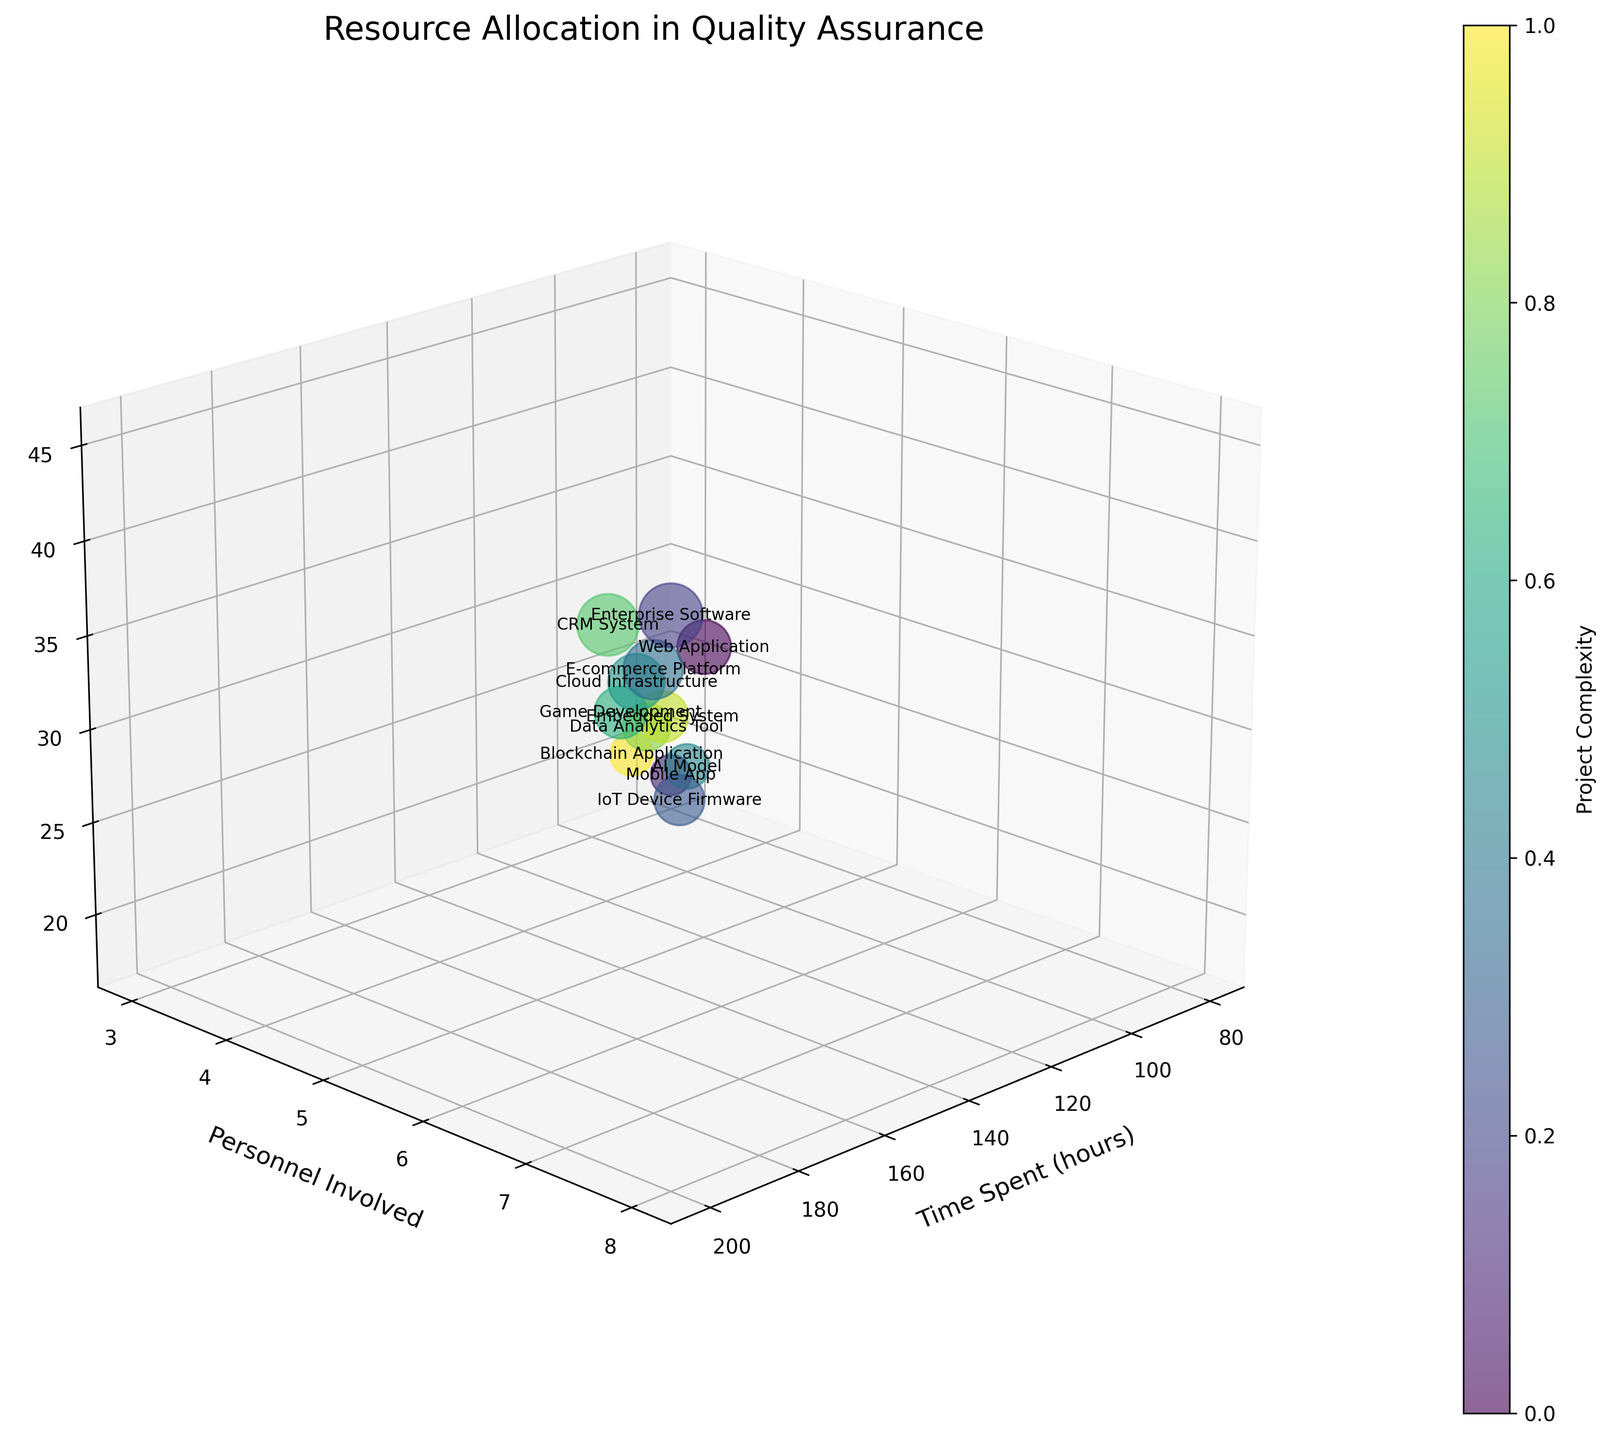What is the title of the figure? The title can be found at the top of the figure, which summarizes the main idea or subject of the plot.
Answer: Resource Allocation in Quality Assurance Which axis represents 'Time Spent (hours)'? The axis labels usually specify what each axis represents. Look for the label that says 'Time Spent (hours)'.
Answer: X-axis How many project types are represented in the figure? Count the unique labels associated with each bubble in the scatter plot to determine the number of project types.
Answer: 12 Which project type involves the most personnel? Identify the bubble with the highest value on the 'Personnel Involved' axis and see which project type is tagged.
Answer: Enterprise Software How many defects are resolved for the Mobile App project type? Look for the bubble labeled 'Mobile App' and identify the value on the 'Defects Resolved' axis.
Answer: 18 Which two project types have the closest number of defects resolved? Compare the values on the 'Defects Resolved' axis for each project type and find the two which are closest in number.
Answer: AI Model and Blockchain Application What is the range of time spent across all project types? Identify the minimum and maximum values on the 'Time Spent (hours)' axis and compute the difference.
Answer: 200 - 80 = 120 What is the average number of personnel involved across all project types? Add up all the values on the 'Personnel Involved' axis and divide by the number of project types.
Answer: (5 + 3 + 8 + 6 + 7 + 4 + 6 + 5 + 7 + 4 + 5 + 3) / 12 = 63 / 12 ≈ 5.25 Which project type resolved the most defects in the least amount of time? Compare the bubbles based on the highest 'Defects Resolved' and lowest 'Time Spent (hours)', then identify the project type.
Answer: Web Application How does time spent correlate with the number of defects resolved? Observe the general trend of the bubbles moving from left to right and bottom to top to infer the correlation between 'Time Spent (hours)' and 'Defects Resolved'.
Answer: Positive correlation 